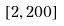<formula> <loc_0><loc_0><loc_500><loc_500>[ 2 , 2 0 0 ]</formula> 